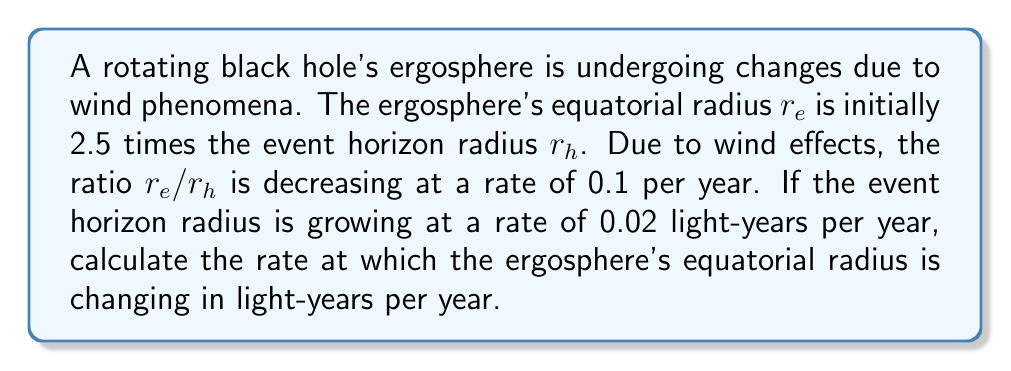Teach me how to tackle this problem. Let's approach this step-by-step:

1) Let $r_e$ be the ergosphere's equatorial radius and $r_h$ be the event horizon radius.

2) Initially, we have:
   $$\frac{r_e}{r_h} = 2.5$$

3) The rate of change of this ratio is given:
   $$\frac{d}{dt}\left(\frac{r_e}{r_h}\right) = -0.1 \text{ per year}$$

4) We're also given that $r_h$ is growing:
   $$\frac{dr_h}{dt} = 0.02 \text{ light-years per year}$$

5) We need to find $\frac{dr_e}{dt}$. Let's use the product rule:
   $$\frac{d}{dt}\left(\frac{r_e}{r_h}\right) = \frac{1}{r_h}\frac{dr_e}{dt} - \frac{r_e}{r_h^2}\frac{dr_h}{dt}$$

6) Rearranging this equation:
   $$\frac{dr_e}{dt} = r_h\frac{d}{dt}\left(\frac{r_e}{r_h}\right) + \frac{r_e}{r_h}\frac{dr_h}{dt}$$

7) Substituting the known values:
   $$\frac{dr_e}{dt} = r_h(-0.1) + 2.5(0.02)$$

8) Simplify:
   $$\frac{dr_e}{dt} = -0.1r_h + 0.05$$

9) We don't know the actual value of $r_h$, but we can express the final answer in terms of $r_h$:
   $$\frac{dr_e}{dt} = 0.05 - 0.1r_h \text{ light-years per year}$$

This equation gives us the rate of change of the ergosphere's equatorial radius as a function of the event horizon radius.
Answer: The rate of change of the ergosphere's equatorial radius is $0.05 - 0.1r_h$ light-years per year, where $r_h$ is the radius of the event horizon in light-years. 